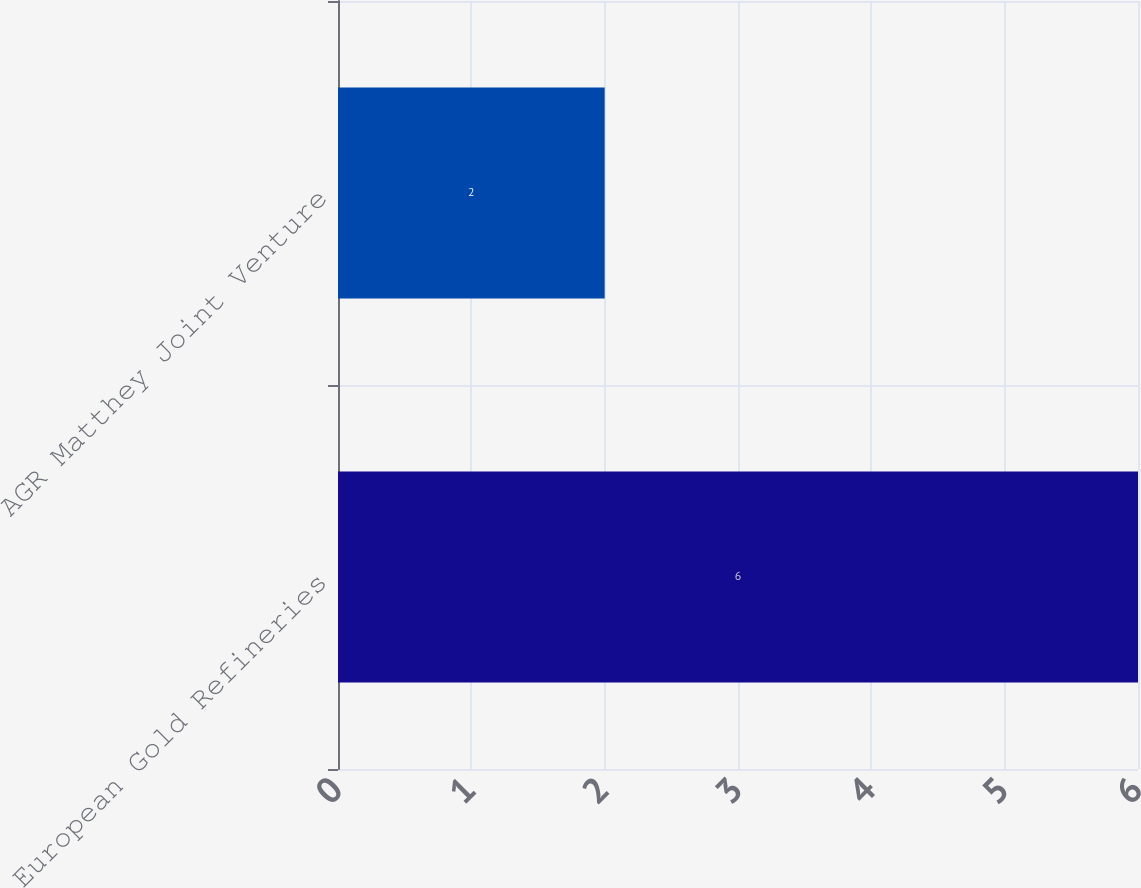Convert chart. <chart><loc_0><loc_0><loc_500><loc_500><bar_chart><fcel>European Gold Refineries<fcel>AGR Matthey Joint Venture<nl><fcel>6<fcel>2<nl></chart> 